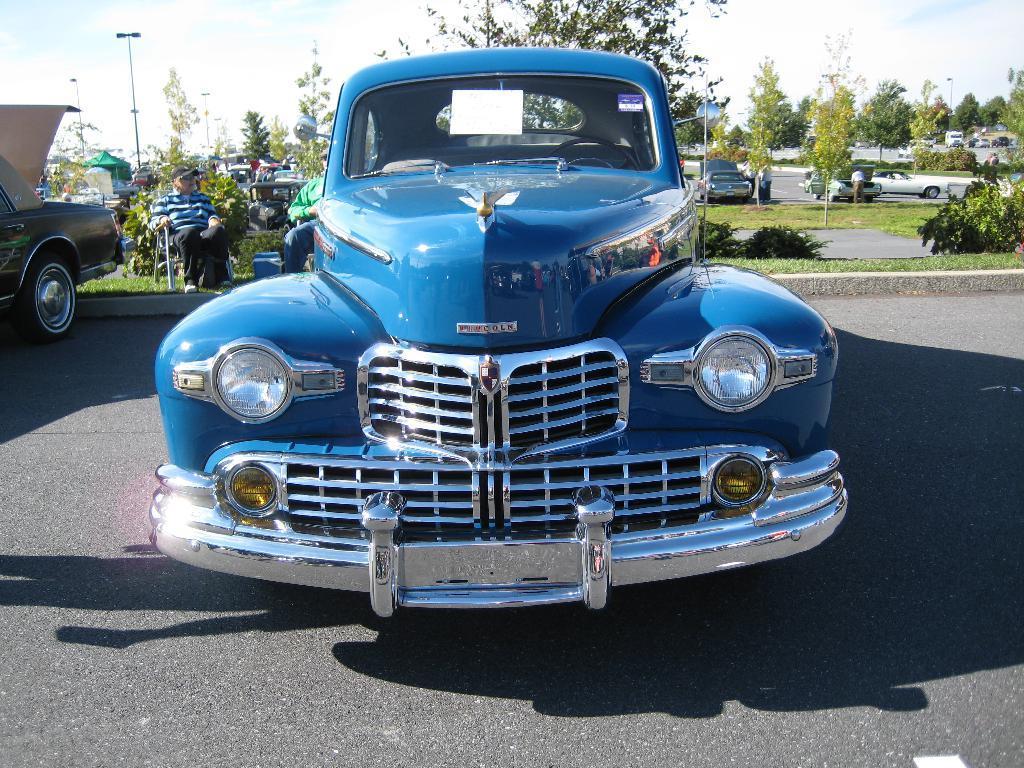Can you describe this image briefly? In this image we can see many vehicles. In the back there are trees. Also there are few people sitting. In the background there is sky with clouds. Also we can see roads in the background. 